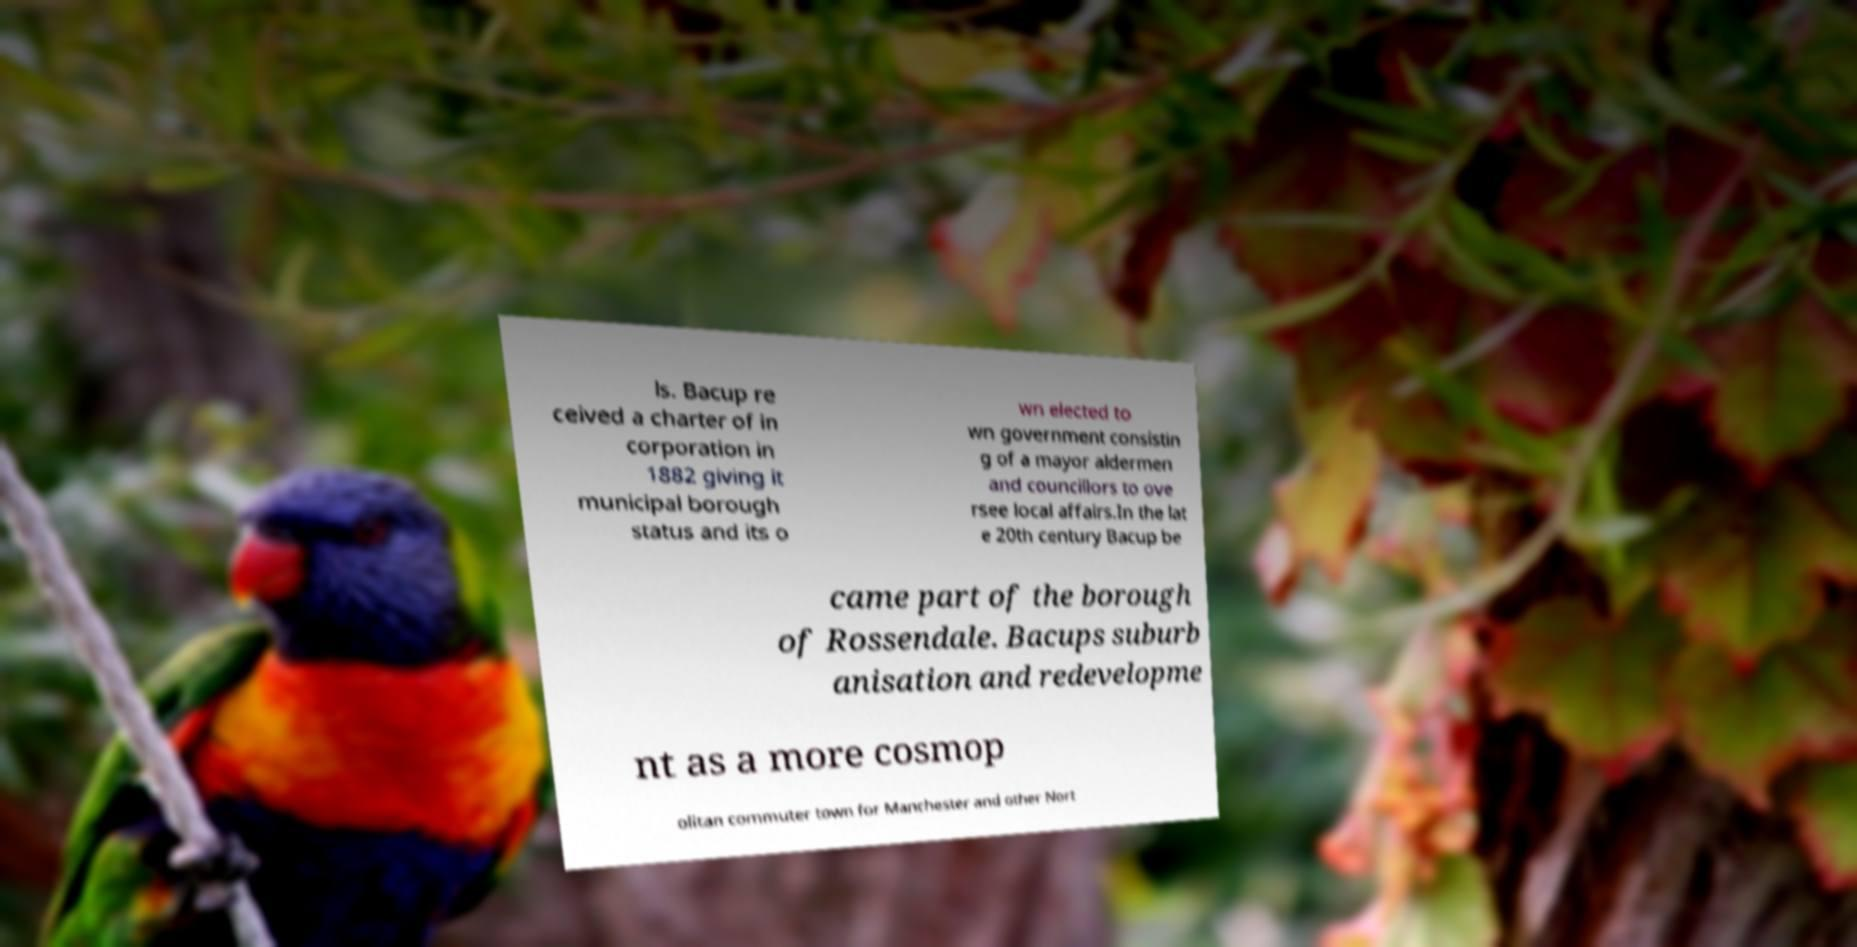Please identify and transcribe the text found in this image. ls. Bacup re ceived a charter of in corporation in 1882 giving it municipal borough status and its o wn elected to wn government consistin g of a mayor aldermen and councillors to ove rsee local affairs.In the lat e 20th century Bacup be came part of the borough of Rossendale. Bacups suburb anisation and redevelopme nt as a more cosmop olitan commuter town for Manchester and other Nort 